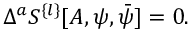Convert formula to latex. <formula><loc_0><loc_0><loc_500><loc_500>\Delta ^ { a } S ^ { \{ l \} } [ A , \psi , \bar { \psi } ] = 0 .</formula> 